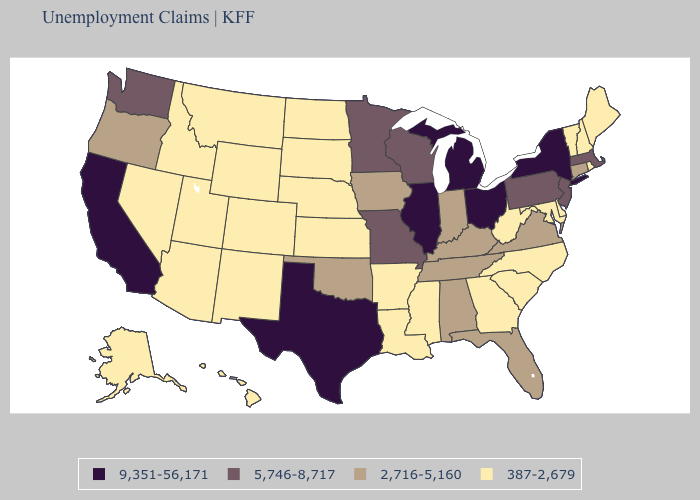Which states have the highest value in the USA?
Be succinct. California, Illinois, Michigan, New York, Ohio, Texas. Does Hawaii have the lowest value in the USA?
Write a very short answer. Yes. Which states hav the highest value in the West?
Keep it brief. California. Which states have the lowest value in the South?
Be succinct. Arkansas, Delaware, Georgia, Louisiana, Maryland, Mississippi, North Carolina, South Carolina, West Virginia. What is the value of Nebraska?
Short answer required. 387-2,679. Does the first symbol in the legend represent the smallest category?
Concise answer only. No. Does North Carolina have a higher value than South Dakota?
Keep it brief. No. What is the highest value in the MidWest ?
Write a very short answer. 9,351-56,171. What is the lowest value in the USA?
Concise answer only. 387-2,679. What is the value of Pennsylvania?
Keep it brief. 5,746-8,717. Name the states that have a value in the range 9,351-56,171?
Write a very short answer. California, Illinois, Michigan, New York, Ohio, Texas. Among the states that border Kentucky , which have the highest value?
Write a very short answer. Illinois, Ohio. Which states have the lowest value in the USA?
Write a very short answer. Alaska, Arizona, Arkansas, Colorado, Delaware, Georgia, Hawaii, Idaho, Kansas, Louisiana, Maine, Maryland, Mississippi, Montana, Nebraska, Nevada, New Hampshire, New Mexico, North Carolina, North Dakota, Rhode Island, South Carolina, South Dakota, Utah, Vermont, West Virginia, Wyoming. What is the value of Montana?
Be succinct. 387-2,679. Name the states that have a value in the range 2,716-5,160?
Keep it brief. Alabama, Connecticut, Florida, Indiana, Iowa, Kentucky, Oklahoma, Oregon, Tennessee, Virginia. 